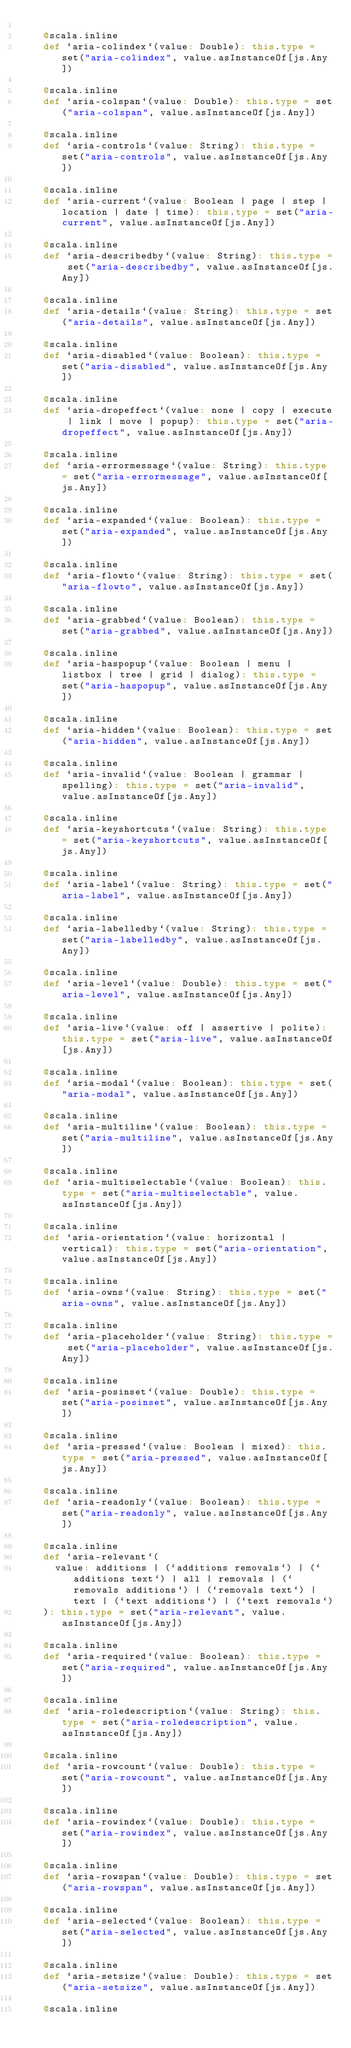<code> <loc_0><loc_0><loc_500><loc_500><_Scala_>    
    @scala.inline
    def `aria-colindex`(value: Double): this.type = set("aria-colindex", value.asInstanceOf[js.Any])
    
    @scala.inline
    def `aria-colspan`(value: Double): this.type = set("aria-colspan", value.asInstanceOf[js.Any])
    
    @scala.inline
    def `aria-controls`(value: String): this.type = set("aria-controls", value.asInstanceOf[js.Any])
    
    @scala.inline
    def `aria-current`(value: Boolean | page | step | location | date | time): this.type = set("aria-current", value.asInstanceOf[js.Any])
    
    @scala.inline
    def `aria-describedby`(value: String): this.type = set("aria-describedby", value.asInstanceOf[js.Any])
    
    @scala.inline
    def `aria-details`(value: String): this.type = set("aria-details", value.asInstanceOf[js.Any])
    
    @scala.inline
    def `aria-disabled`(value: Boolean): this.type = set("aria-disabled", value.asInstanceOf[js.Any])
    
    @scala.inline
    def `aria-dropeffect`(value: none | copy | execute | link | move | popup): this.type = set("aria-dropeffect", value.asInstanceOf[js.Any])
    
    @scala.inline
    def `aria-errormessage`(value: String): this.type = set("aria-errormessage", value.asInstanceOf[js.Any])
    
    @scala.inline
    def `aria-expanded`(value: Boolean): this.type = set("aria-expanded", value.asInstanceOf[js.Any])
    
    @scala.inline
    def `aria-flowto`(value: String): this.type = set("aria-flowto", value.asInstanceOf[js.Any])
    
    @scala.inline
    def `aria-grabbed`(value: Boolean): this.type = set("aria-grabbed", value.asInstanceOf[js.Any])
    
    @scala.inline
    def `aria-haspopup`(value: Boolean | menu | listbox | tree | grid | dialog): this.type = set("aria-haspopup", value.asInstanceOf[js.Any])
    
    @scala.inline
    def `aria-hidden`(value: Boolean): this.type = set("aria-hidden", value.asInstanceOf[js.Any])
    
    @scala.inline
    def `aria-invalid`(value: Boolean | grammar | spelling): this.type = set("aria-invalid", value.asInstanceOf[js.Any])
    
    @scala.inline
    def `aria-keyshortcuts`(value: String): this.type = set("aria-keyshortcuts", value.asInstanceOf[js.Any])
    
    @scala.inline
    def `aria-label`(value: String): this.type = set("aria-label", value.asInstanceOf[js.Any])
    
    @scala.inline
    def `aria-labelledby`(value: String): this.type = set("aria-labelledby", value.asInstanceOf[js.Any])
    
    @scala.inline
    def `aria-level`(value: Double): this.type = set("aria-level", value.asInstanceOf[js.Any])
    
    @scala.inline
    def `aria-live`(value: off | assertive | polite): this.type = set("aria-live", value.asInstanceOf[js.Any])
    
    @scala.inline
    def `aria-modal`(value: Boolean): this.type = set("aria-modal", value.asInstanceOf[js.Any])
    
    @scala.inline
    def `aria-multiline`(value: Boolean): this.type = set("aria-multiline", value.asInstanceOf[js.Any])
    
    @scala.inline
    def `aria-multiselectable`(value: Boolean): this.type = set("aria-multiselectable", value.asInstanceOf[js.Any])
    
    @scala.inline
    def `aria-orientation`(value: horizontal | vertical): this.type = set("aria-orientation", value.asInstanceOf[js.Any])
    
    @scala.inline
    def `aria-owns`(value: String): this.type = set("aria-owns", value.asInstanceOf[js.Any])
    
    @scala.inline
    def `aria-placeholder`(value: String): this.type = set("aria-placeholder", value.asInstanceOf[js.Any])
    
    @scala.inline
    def `aria-posinset`(value: Double): this.type = set("aria-posinset", value.asInstanceOf[js.Any])
    
    @scala.inline
    def `aria-pressed`(value: Boolean | mixed): this.type = set("aria-pressed", value.asInstanceOf[js.Any])
    
    @scala.inline
    def `aria-readonly`(value: Boolean): this.type = set("aria-readonly", value.asInstanceOf[js.Any])
    
    @scala.inline
    def `aria-relevant`(
      value: additions | (`additions removals`) | (`additions text`) | all | removals | (`removals additions`) | (`removals text`) | text | (`text additions`) | (`text removals`)
    ): this.type = set("aria-relevant", value.asInstanceOf[js.Any])
    
    @scala.inline
    def `aria-required`(value: Boolean): this.type = set("aria-required", value.asInstanceOf[js.Any])
    
    @scala.inline
    def `aria-roledescription`(value: String): this.type = set("aria-roledescription", value.asInstanceOf[js.Any])
    
    @scala.inline
    def `aria-rowcount`(value: Double): this.type = set("aria-rowcount", value.asInstanceOf[js.Any])
    
    @scala.inline
    def `aria-rowindex`(value: Double): this.type = set("aria-rowindex", value.asInstanceOf[js.Any])
    
    @scala.inline
    def `aria-rowspan`(value: Double): this.type = set("aria-rowspan", value.asInstanceOf[js.Any])
    
    @scala.inline
    def `aria-selected`(value: Boolean): this.type = set("aria-selected", value.asInstanceOf[js.Any])
    
    @scala.inline
    def `aria-setsize`(value: Double): this.type = set("aria-setsize", value.asInstanceOf[js.Any])
    
    @scala.inline</code> 